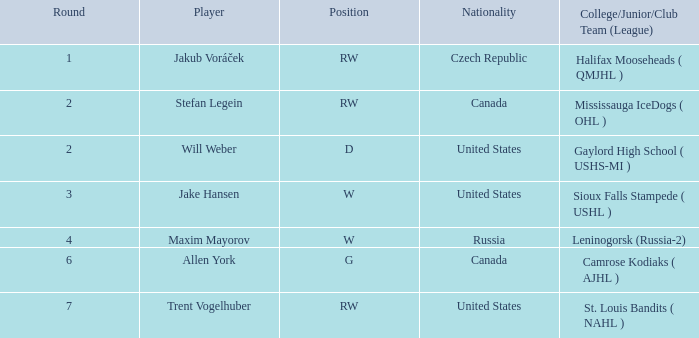From leninogorsk (russia-2), what is the nationality of the player in the w position who was drafted? Russia. 